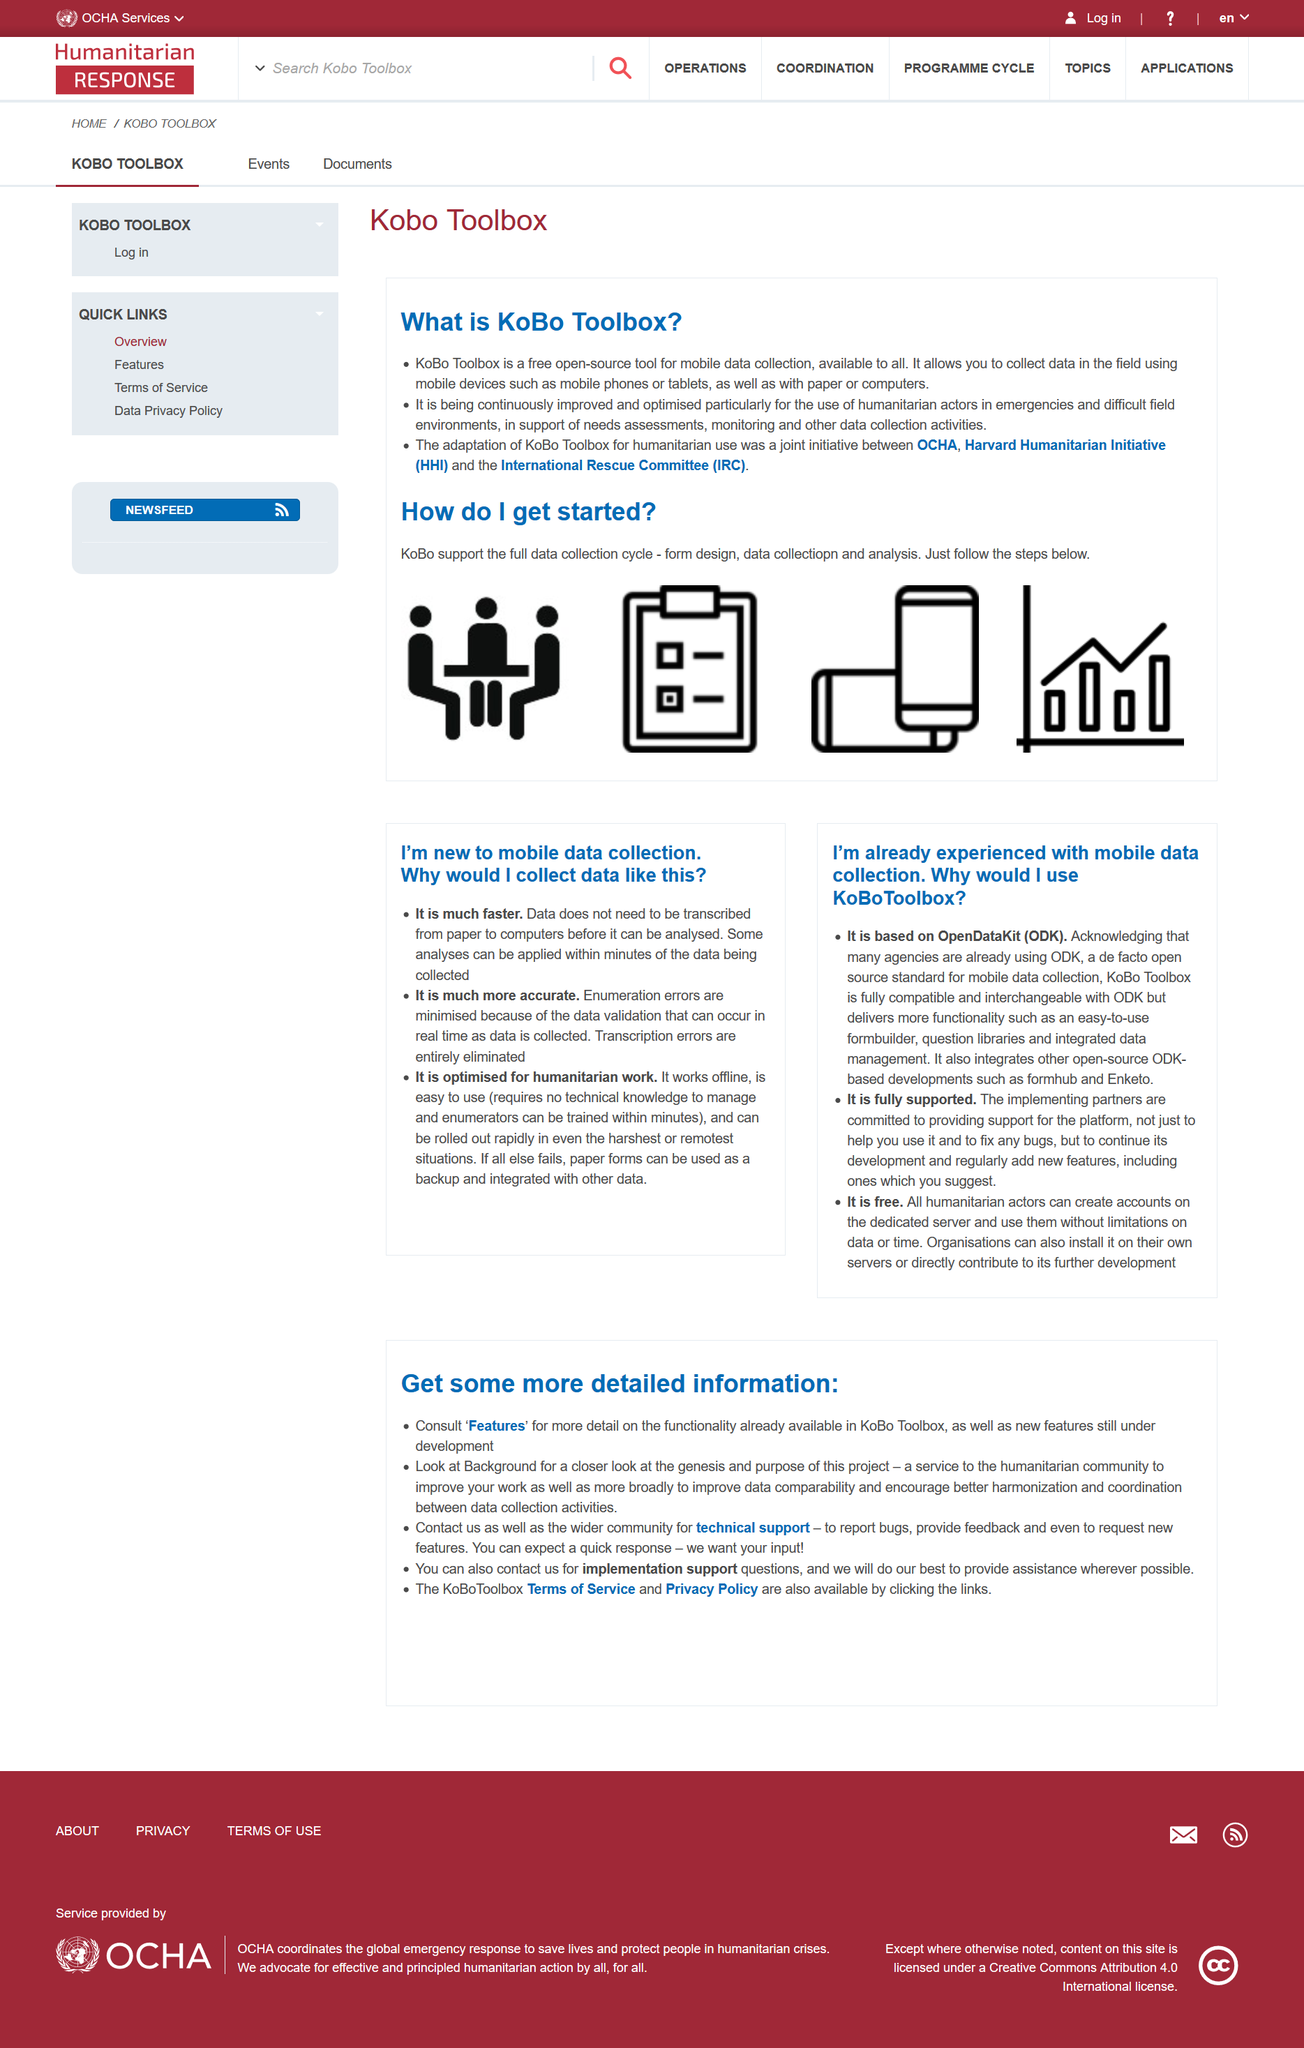Draw attention to some important aspects in this diagram. Yes, it is free to use KoboToolbox. There are 3 reasons provided that demonstrate the benefits of mobile data collection. The process of getting started involves following the steps outlined below. You can receive both technical and implementation support by contacting The KoBo Toolbox directly, including assistance with data collection, data management, and the use of KoBo Toolbox software. KoBoToolbox is a software platform that is built upon the OpenDataKit framework, which provides a set of tools for working with data in the field. 